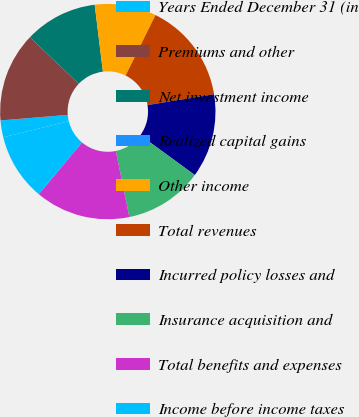Convert chart to OTSL. <chart><loc_0><loc_0><loc_500><loc_500><pie_chart><fcel>Years Ended December 31 (in<fcel>Premiums and other<fcel>Net investment income<fcel>Realized capital gains<fcel>Other income<fcel>Total revenues<fcel>Incurred policy losses and<fcel>Insurance acquisition and<fcel>Total benefits and expenses<fcel>Income before income taxes<nl><fcel>2.52%<fcel>13.44%<fcel>10.92%<fcel>0.0%<fcel>9.24%<fcel>15.12%<fcel>12.6%<fcel>11.76%<fcel>14.28%<fcel>10.08%<nl></chart> 